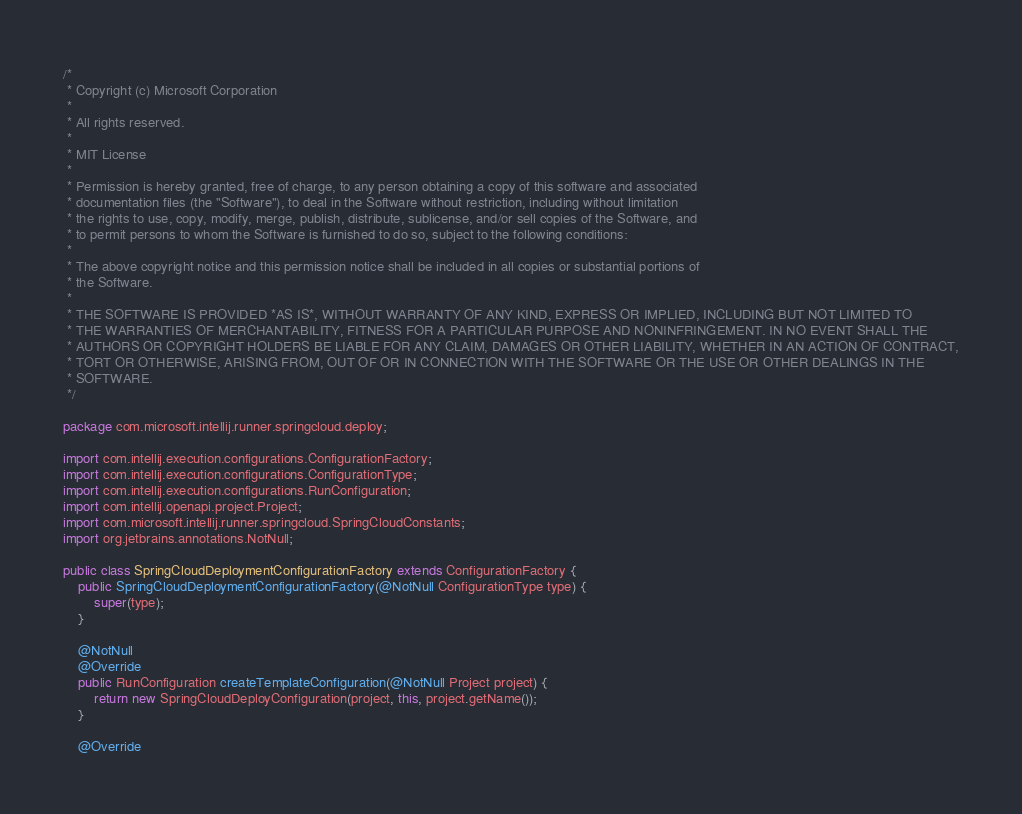Convert code to text. <code><loc_0><loc_0><loc_500><loc_500><_Java_>/*
 * Copyright (c) Microsoft Corporation
 *
 * All rights reserved.
 *
 * MIT License
 *
 * Permission is hereby granted, free of charge, to any person obtaining a copy of this software and associated
 * documentation files (the "Software"), to deal in the Software without restriction, including without limitation
 * the rights to use, copy, modify, merge, publish, distribute, sublicense, and/or sell copies of the Software, and
 * to permit persons to whom the Software is furnished to do so, subject to the following conditions:
 *
 * The above copyright notice and this permission notice shall be included in all copies or substantial portions of
 * the Software.
 *
 * THE SOFTWARE IS PROVIDED *AS IS*, WITHOUT WARRANTY OF ANY KIND, EXPRESS OR IMPLIED, INCLUDING BUT NOT LIMITED TO
 * THE WARRANTIES OF MERCHANTABILITY, FITNESS FOR A PARTICULAR PURPOSE AND NONINFRINGEMENT. IN NO EVENT SHALL THE
 * AUTHORS OR COPYRIGHT HOLDERS BE LIABLE FOR ANY CLAIM, DAMAGES OR OTHER LIABILITY, WHETHER IN AN ACTION OF CONTRACT,
 * TORT OR OTHERWISE, ARISING FROM, OUT OF OR IN CONNECTION WITH THE SOFTWARE OR THE USE OR OTHER DEALINGS IN THE
 * SOFTWARE.
 */

package com.microsoft.intellij.runner.springcloud.deploy;

import com.intellij.execution.configurations.ConfigurationFactory;
import com.intellij.execution.configurations.ConfigurationType;
import com.intellij.execution.configurations.RunConfiguration;
import com.intellij.openapi.project.Project;
import com.microsoft.intellij.runner.springcloud.SpringCloudConstants;
import org.jetbrains.annotations.NotNull;

public class SpringCloudDeploymentConfigurationFactory extends ConfigurationFactory {
    public SpringCloudDeploymentConfigurationFactory(@NotNull ConfigurationType type) {
        super(type);
    }

    @NotNull
    @Override
    public RunConfiguration createTemplateConfiguration(@NotNull Project project) {
        return new SpringCloudDeployConfiguration(project, this, project.getName());
    }

    @Override</code> 